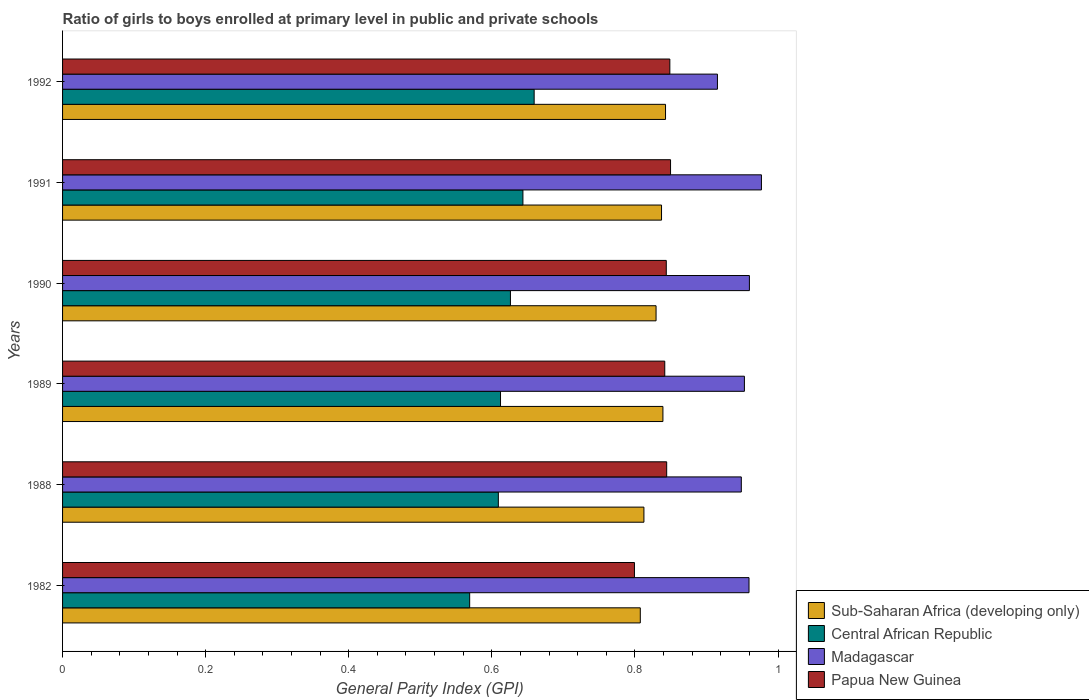How many different coloured bars are there?
Provide a short and direct response. 4. Are the number of bars per tick equal to the number of legend labels?
Offer a terse response. Yes. How many bars are there on the 6th tick from the bottom?
Offer a very short reply. 4. What is the label of the 5th group of bars from the top?
Make the answer very short. 1988. In how many cases, is the number of bars for a given year not equal to the number of legend labels?
Give a very brief answer. 0. What is the general parity index in Sub-Saharan Africa (developing only) in 1989?
Offer a terse response. 0.84. Across all years, what is the maximum general parity index in Papua New Guinea?
Make the answer very short. 0.85. Across all years, what is the minimum general parity index in Sub-Saharan Africa (developing only)?
Give a very brief answer. 0.81. In which year was the general parity index in Central African Republic maximum?
Your response must be concise. 1992. In which year was the general parity index in Madagascar minimum?
Offer a terse response. 1992. What is the total general parity index in Sub-Saharan Africa (developing only) in the graph?
Provide a succinct answer. 4.97. What is the difference between the general parity index in Sub-Saharan Africa (developing only) in 1988 and that in 1989?
Make the answer very short. -0.03. What is the difference between the general parity index in Sub-Saharan Africa (developing only) in 1991 and the general parity index in Papua New Guinea in 1989?
Ensure brevity in your answer.  -0. What is the average general parity index in Papua New Guinea per year?
Your answer should be very brief. 0.84. In the year 1992, what is the difference between the general parity index in Sub-Saharan Africa (developing only) and general parity index in Madagascar?
Ensure brevity in your answer.  -0.07. What is the ratio of the general parity index in Central African Republic in 1989 to that in 1991?
Provide a short and direct response. 0.95. Is the general parity index in Madagascar in 1989 less than that in 1991?
Offer a very short reply. Yes. Is the difference between the general parity index in Sub-Saharan Africa (developing only) in 1988 and 1992 greater than the difference between the general parity index in Madagascar in 1988 and 1992?
Make the answer very short. No. What is the difference between the highest and the second highest general parity index in Papua New Guinea?
Your response must be concise. 0. What is the difference between the highest and the lowest general parity index in Papua New Guinea?
Keep it short and to the point. 0.05. Is it the case that in every year, the sum of the general parity index in Papua New Guinea and general parity index in Central African Republic is greater than the sum of general parity index in Sub-Saharan Africa (developing only) and general parity index in Madagascar?
Offer a very short reply. No. What does the 3rd bar from the top in 1982 represents?
Your answer should be compact. Central African Republic. What does the 1st bar from the bottom in 1992 represents?
Offer a very short reply. Sub-Saharan Africa (developing only). Is it the case that in every year, the sum of the general parity index in Central African Republic and general parity index in Madagascar is greater than the general parity index in Sub-Saharan Africa (developing only)?
Ensure brevity in your answer.  Yes. What is the difference between two consecutive major ticks on the X-axis?
Your answer should be very brief. 0.2. Are the values on the major ticks of X-axis written in scientific E-notation?
Provide a short and direct response. No. Does the graph contain any zero values?
Give a very brief answer. No. Does the graph contain grids?
Provide a short and direct response. No. Where does the legend appear in the graph?
Keep it short and to the point. Bottom right. How are the legend labels stacked?
Keep it short and to the point. Vertical. What is the title of the graph?
Keep it short and to the point. Ratio of girls to boys enrolled at primary level in public and private schools. What is the label or title of the X-axis?
Offer a terse response. General Parity Index (GPI). What is the label or title of the Y-axis?
Your answer should be compact. Years. What is the General Parity Index (GPI) in Sub-Saharan Africa (developing only) in 1982?
Offer a very short reply. 0.81. What is the General Parity Index (GPI) in Central African Republic in 1982?
Your answer should be compact. 0.57. What is the General Parity Index (GPI) in Madagascar in 1982?
Provide a short and direct response. 0.96. What is the General Parity Index (GPI) in Papua New Guinea in 1982?
Ensure brevity in your answer.  0.8. What is the General Parity Index (GPI) of Sub-Saharan Africa (developing only) in 1988?
Provide a short and direct response. 0.81. What is the General Parity Index (GPI) in Central African Republic in 1988?
Keep it short and to the point. 0.61. What is the General Parity Index (GPI) in Madagascar in 1988?
Provide a short and direct response. 0.95. What is the General Parity Index (GPI) of Papua New Guinea in 1988?
Make the answer very short. 0.84. What is the General Parity Index (GPI) of Sub-Saharan Africa (developing only) in 1989?
Your answer should be very brief. 0.84. What is the General Parity Index (GPI) in Central African Republic in 1989?
Provide a short and direct response. 0.61. What is the General Parity Index (GPI) in Madagascar in 1989?
Ensure brevity in your answer.  0.95. What is the General Parity Index (GPI) of Papua New Guinea in 1989?
Provide a succinct answer. 0.84. What is the General Parity Index (GPI) of Sub-Saharan Africa (developing only) in 1990?
Provide a succinct answer. 0.83. What is the General Parity Index (GPI) of Central African Republic in 1990?
Your response must be concise. 0.63. What is the General Parity Index (GPI) in Papua New Guinea in 1990?
Offer a terse response. 0.84. What is the General Parity Index (GPI) of Sub-Saharan Africa (developing only) in 1991?
Your answer should be very brief. 0.84. What is the General Parity Index (GPI) in Central African Republic in 1991?
Offer a very short reply. 0.64. What is the General Parity Index (GPI) in Madagascar in 1991?
Ensure brevity in your answer.  0.98. What is the General Parity Index (GPI) of Papua New Guinea in 1991?
Offer a terse response. 0.85. What is the General Parity Index (GPI) in Sub-Saharan Africa (developing only) in 1992?
Give a very brief answer. 0.84. What is the General Parity Index (GPI) of Central African Republic in 1992?
Ensure brevity in your answer.  0.66. What is the General Parity Index (GPI) of Madagascar in 1992?
Ensure brevity in your answer.  0.92. What is the General Parity Index (GPI) in Papua New Guinea in 1992?
Keep it short and to the point. 0.85. Across all years, what is the maximum General Parity Index (GPI) of Sub-Saharan Africa (developing only)?
Provide a succinct answer. 0.84. Across all years, what is the maximum General Parity Index (GPI) in Central African Republic?
Your answer should be very brief. 0.66. Across all years, what is the maximum General Parity Index (GPI) in Madagascar?
Provide a short and direct response. 0.98. Across all years, what is the maximum General Parity Index (GPI) of Papua New Guinea?
Provide a short and direct response. 0.85. Across all years, what is the minimum General Parity Index (GPI) of Sub-Saharan Africa (developing only)?
Provide a succinct answer. 0.81. Across all years, what is the minimum General Parity Index (GPI) in Central African Republic?
Your answer should be compact. 0.57. Across all years, what is the minimum General Parity Index (GPI) of Madagascar?
Your answer should be compact. 0.92. Across all years, what is the minimum General Parity Index (GPI) of Papua New Guinea?
Offer a terse response. 0.8. What is the total General Parity Index (GPI) of Sub-Saharan Africa (developing only) in the graph?
Make the answer very short. 4.97. What is the total General Parity Index (GPI) of Central African Republic in the graph?
Offer a terse response. 3.72. What is the total General Parity Index (GPI) in Madagascar in the graph?
Your response must be concise. 5.71. What is the total General Parity Index (GPI) in Papua New Guinea in the graph?
Offer a terse response. 5.03. What is the difference between the General Parity Index (GPI) of Sub-Saharan Africa (developing only) in 1982 and that in 1988?
Ensure brevity in your answer.  -0.01. What is the difference between the General Parity Index (GPI) of Central African Republic in 1982 and that in 1988?
Keep it short and to the point. -0.04. What is the difference between the General Parity Index (GPI) in Madagascar in 1982 and that in 1988?
Provide a succinct answer. 0.01. What is the difference between the General Parity Index (GPI) of Papua New Guinea in 1982 and that in 1988?
Your answer should be compact. -0.05. What is the difference between the General Parity Index (GPI) in Sub-Saharan Africa (developing only) in 1982 and that in 1989?
Provide a short and direct response. -0.03. What is the difference between the General Parity Index (GPI) of Central African Republic in 1982 and that in 1989?
Your response must be concise. -0.04. What is the difference between the General Parity Index (GPI) in Madagascar in 1982 and that in 1989?
Give a very brief answer. 0.01. What is the difference between the General Parity Index (GPI) of Papua New Guinea in 1982 and that in 1989?
Your answer should be very brief. -0.04. What is the difference between the General Parity Index (GPI) of Sub-Saharan Africa (developing only) in 1982 and that in 1990?
Provide a succinct answer. -0.02. What is the difference between the General Parity Index (GPI) of Central African Republic in 1982 and that in 1990?
Your answer should be very brief. -0.06. What is the difference between the General Parity Index (GPI) in Madagascar in 1982 and that in 1990?
Provide a succinct answer. -0. What is the difference between the General Parity Index (GPI) in Papua New Guinea in 1982 and that in 1990?
Give a very brief answer. -0.04. What is the difference between the General Parity Index (GPI) in Sub-Saharan Africa (developing only) in 1982 and that in 1991?
Your answer should be compact. -0.03. What is the difference between the General Parity Index (GPI) of Central African Republic in 1982 and that in 1991?
Offer a very short reply. -0.07. What is the difference between the General Parity Index (GPI) of Madagascar in 1982 and that in 1991?
Keep it short and to the point. -0.02. What is the difference between the General Parity Index (GPI) of Papua New Guinea in 1982 and that in 1991?
Your answer should be very brief. -0.05. What is the difference between the General Parity Index (GPI) in Sub-Saharan Africa (developing only) in 1982 and that in 1992?
Give a very brief answer. -0.04. What is the difference between the General Parity Index (GPI) in Central African Republic in 1982 and that in 1992?
Your answer should be compact. -0.09. What is the difference between the General Parity Index (GPI) in Madagascar in 1982 and that in 1992?
Provide a short and direct response. 0.04. What is the difference between the General Parity Index (GPI) of Papua New Guinea in 1982 and that in 1992?
Your answer should be very brief. -0.05. What is the difference between the General Parity Index (GPI) of Sub-Saharan Africa (developing only) in 1988 and that in 1989?
Give a very brief answer. -0.03. What is the difference between the General Parity Index (GPI) in Central African Republic in 1988 and that in 1989?
Provide a short and direct response. -0. What is the difference between the General Parity Index (GPI) in Madagascar in 1988 and that in 1989?
Offer a terse response. -0. What is the difference between the General Parity Index (GPI) of Papua New Guinea in 1988 and that in 1989?
Your answer should be compact. 0. What is the difference between the General Parity Index (GPI) of Sub-Saharan Africa (developing only) in 1988 and that in 1990?
Your answer should be compact. -0.02. What is the difference between the General Parity Index (GPI) of Central African Republic in 1988 and that in 1990?
Your answer should be compact. -0.02. What is the difference between the General Parity Index (GPI) in Madagascar in 1988 and that in 1990?
Offer a very short reply. -0.01. What is the difference between the General Parity Index (GPI) of Papua New Guinea in 1988 and that in 1990?
Provide a short and direct response. 0. What is the difference between the General Parity Index (GPI) in Sub-Saharan Africa (developing only) in 1988 and that in 1991?
Give a very brief answer. -0.02. What is the difference between the General Parity Index (GPI) of Central African Republic in 1988 and that in 1991?
Provide a short and direct response. -0.03. What is the difference between the General Parity Index (GPI) in Madagascar in 1988 and that in 1991?
Make the answer very short. -0.03. What is the difference between the General Parity Index (GPI) in Papua New Guinea in 1988 and that in 1991?
Your response must be concise. -0.01. What is the difference between the General Parity Index (GPI) in Sub-Saharan Africa (developing only) in 1988 and that in 1992?
Give a very brief answer. -0.03. What is the difference between the General Parity Index (GPI) of Central African Republic in 1988 and that in 1992?
Offer a very short reply. -0.05. What is the difference between the General Parity Index (GPI) of Madagascar in 1988 and that in 1992?
Keep it short and to the point. 0.03. What is the difference between the General Parity Index (GPI) of Papua New Guinea in 1988 and that in 1992?
Offer a very short reply. -0. What is the difference between the General Parity Index (GPI) in Sub-Saharan Africa (developing only) in 1989 and that in 1990?
Ensure brevity in your answer.  0.01. What is the difference between the General Parity Index (GPI) of Central African Republic in 1989 and that in 1990?
Give a very brief answer. -0.01. What is the difference between the General Parity Index (GPI) of Madagascar in 1989 and that in 1990?
Your answer should be very brief. -0.01. What is the difference between the General Parity Index (GPI) in Papua New Guinea in 1989 and that in 1990?
Provide a short and direct response. -0. What is the difference between the General Parity Index (GPI) of Sub-Saharan Africa (developing only) in 1989 and that in 1991?
Your answer should be very brief. 0. What is the difference between the General Parity Index (GPI) in Central African Republic in 1989 and that in 1991?
Provide a succinct answer. -0.03. What is the difference between the General Parity Index (GPI) of Madagascar in 1989 and that in 1991?
Your response must be concise. -0.02. What is the difference between the General Parity Index (GPI) in Papua New Guinea in 1989 and that in 1991?
Your response must be concise. -0.01. What is the difference between the General Parity Index (GPI) of Sub-Saharan Africa (developing only) in 1989 and that in 1992?
Offer a terse response. -0. What is the difference between the General Parity Index (GPI) of Central African Republic in 1989 and that in 1992?
Provide a succinct answer. -0.05. What is the difference between the General Parity Index (GPI) of Madagascar in 1989 and that in 1992?
Give a very brief answer. 0.04. What is the difference between the General Parity Index (GPI) of Papua New Guinea in 1989 and that in 1992?
Your response must be concise. -0.01. What is the difference between the General Parity Index (GPI) in Sub-Saharan Africa (developing only) in 1990 and that in 1991?
Provide a succinct answer. -0.01. What is the difference between the General Parity Index (GPI) of Central African Republic in 1990 and that in 1991?
Keep it short and to the point. -0.02. What is the difference between the General Parity Index (GPI) of Madagascar in 1990 and that in 1991?
Make the answer very short. -0.02. What is the difference between the General Parity Index (GPI) of Papua New Guinea in 1990 and that in 1991?
Make the answer very short. -0.01. What is the difference between the General Parity Index (GPI) in Sub-Saharan Africa (developing only) in 1990 and that in 1992?
Offer a terse response. -0.01. What is the difference between the General Parity Index (GPI) in Central African Republic in 1990 and that in 1992?
Give a very brief answer. -0.03. What is the difference between the General Parity Index (GPI) of Madagascar in 1990 and that in 1992?
Keep it short and to the point. 0.04. What is the difference between the General Parity Index (GPI) of Papua New Guinea in 1990 and that in 1992?
Your answer should be very brief. -0.01. What is the difference between the General Parity Index (GPI) of Sub-Saharan Africa (developing only) in 1991 and that in 1992?
Offer a terse response. -0.01. What is the difference between the General Parity Index (GPI) of Central African Republic in 1991 and that in 1992?
Give a very brief answer. -0.02. What is the difference between the General Parity Index (GPI) of Madagascar in 1991 and that in 1992?
Keep it short and to the point. 0.06. What is the difference between the General Parity Index (GPI) of Sub-Saharan Africa (developing only) in 1982 and the General Parity Index (GPI) of Central African Republic in 1988?
Ensure brevity in your answer.  0.2. What is the difference between the General Parity Index (GPI) in Sub-Saharan Africa (developing only) in 1982 and the General Parity Index (GPI) in Madagascar in 1988?
Offer a very short reply. -0.14. What is the difference between the General Parity Index (GPI) of Sub-Saharan Africa (developing only) in 1982 and the General Parity Index (GPI) of Papua New Guinea in 1988?
Your answer should be compact. -0.04. What is the difference between the General Parity Index (GPI) in Central African Republic in 1982 and the General Parity Index (GPI) in Madagascar in 1988?
Make the answer very short. -0.38. What is the difference between the General Parity Index (GPI) in Central African Republic in 1982 and the General Parity Index (GPI) in Papua New Guinea in 1988?
Keep it short and to the point. -0.28. What is the difference between the General Parity Index (GPI) in Madagascar in 1982 and the General Parity Index (GPI) in Papua New Guinea in 1988?
Ensure brevity in your answer.  0.12. What is the difference between the General Parity Index (GPI) of Sub-Saharan Africa (developing only) in 1982 and the General Parity Index (GPI) of Central African Republic in 1989?
Offer a very short reply. 0.2. What is the difference between the General Parity Index (GPI) of Sub-Saharan Africa (developing only) in 1982 and the General Parity Index (GPI) of Madagascar in 1989?
Give a very brief answer. -0.15. What is the difference between the General Parity Index (GPI) in Sub-Saharan Africa (developing only) in 1982 and the General Parity Index (GPI) in Papua New Guinea in 1989?
Your answer should be compact. -0.03. What is the difference between the General Parity Index (GPI) of Central African Republic in 1982 and the General Parity Index (GPI) of Madagascar in 1989?
Provide a short and direct response. -0.38. What is the difference between the General Parity Index (GPI) in Central African Republic in 1982 and the General Parity Index (GPI) in Papua New Guinea in 1989?
Your response must be concise. -0.27. What is the difference between the General Parity Index (GPI) in Madagascar in 1982 and the General Parity Index (GPI) in Papua New Guinea in 1989?
Ensure brevity in your answer.  0.12. What is the difference between the General Parity Index (GPI) in Sub-Saharan Africa (developing only) in 1982 and the General Parity Index (GPI) in Central African Republic in 1990?
Provide a succinct answer. 0.18. What is the difference between the General Parity Index (GPI) of Sub-Saharan Africa (developing only) in 1982 and the General Parity Index (GPI) of Madagascar in 1990?
Provide a short and direct response. -0.15. What is the difference between the General Parity Index (GPI) in Sub-Saharan Africa (developing only) in 1982 and the General Parity Index (GPI) in Papua New Guinea in 1990?
Your response must be concise. -0.04. What is the difference between the General Parity Index (GPI) of Central African Republic in 1982 and the General Parity Index (GPI) of Madagascar in 1990?
Ensure brevity in your answer.  -0.39. What is the difference between the General Parity Index (GPI) in Central African Republic in 1982 and the General Parity Index (GPI) in Papua New Guinea in 1990?
Your answer should be compact. -0.27. What is the difference between the General Parity Index (GPI) of Madagascar in 1982 and the General Parity Index (GPI) of Papua New Guinea in 1990?
Your answer should be compact. 0.12. What is the difference between the General Parity Index (GPI) in Sub-Saharan Africa (developing only) in 1982 and the General Parity Index (GPI) in Central African Republic in 1991?
Keep it short and to the point. 0.16. What is the difference between the General Parity Index (GPI) in Sub-Saharan Africa (developing only) in 1982 and the General Parity Index (GPI) in Madagascar in 1991?
Provide a succinct answer. -0.17. What is the difference between the General Parity Index (GPI) of Sub-Saharan Africa (developing only) in 1982 and the General Parity Index (GPI) of Papua New Guinea in 1991?
Provide a short and direct response. -0.04. What is the difference between the General Parity Index (GPI) in Central African Republic in 1982 and the General Parity Index (GPI) in Madagascar in 1991?
Provide a short and direct response. -0.41. What is the difference between the General Parity Index (GPI) of Central African Republic in 1982 and the General Parity Index (GPI) of Papua New Guinea in 1991?
Provide a short and direct response. -0.28. What is the difference between the General Parity Index (GPI) of Madagascar in 1982 and the General Parity Index (GPI) of Papua New Guinea in 1991?
Ensure brevity in your answer.  0.11. What is the difference between the General Parity Index (GPI) of Sub-Saharan Africa (developing only) in 1982 and the General Parity Index (GPI) of Central African Republic in 1992?
Your answer should be compact. 0.15. What is the difference between the General Parity Index (GPI) of Sub-Saharan Africa (developing only) in 1982 and the General Parity Index (GPI) of Madagascar in 1992?
Ensure brevity in your answer.  -0.11. What is the difference between the General Parity Index (GPI) in Sub-Saharan Africa (developing only) in 1982 and the General Parity Index (GPI) in Papua New Guinea in 1992?
Your answer should be very brief. -0.04. What is the difference between the General Parity Index (GPI) in Central African Republic in 1982 and the General Parity Index (GPI) in Madagascar in 1992?
Your answer should be compact. -0.35. What is the difference between the General Parity Index (GPI) of Central African Republic in 1982 and the General Parity Index (GPI) of Papua New Guinea in 1992?
Offer a terse response. -0.28. What is the difference between the General Parity Index (GPI) of Madagascar in 1982 and the General Parity Index (GPI) of Papua New Guinea in 1992?
Your answer should be very brief. 0.11. What is the difference between the General Parity Index (GPI) in Sub-Saharan Africa (developing only) in 1988 and the General Parity Index (GPI) in Central African Republic in 1989?
Give a very brief answer. 0.2. What is the difference between the General Parity Index (GPI) of Sub-Saharan Africa (developing only) in 1988 and the General Parity Index (GPI) of Madagascar in 1989?
Ensure brevity in your answer.  -0.14. What is the difference between the General Parity Index (GPI) of Sub-Saharan Africa (developing only) in 1988 and the General Parity Index (GPI) of Papua New Guinea in 1989?
Offer a terse response. -0.03. What is the difference between the General Parity Index (GPI) in Central African Republic in 1988 and the General Parity Index (GPI) in Madagascar in 1989?
Ensure brevity in your answer.  -0.34. What is the difference between the General Parity Index (GPI) in Central African Republic in 1988 and the General Parity Index (GPI) in Papua New Guinea in 1989?
Make the answer very short. -0.23. What is the difference between the General Parity Index (GPI) of Madagascar in 1988 and the General Parity Index (GPI) of Papua New Guinea in 1989?
Make the answer very short. 0.11. What is the difference between the General Parity Index (GPI) of Sub-Saharan Africa (developing only) in 1988 and the General Parity Index (GPI) of Central African Republic in 1990?
Make the answer very short. 0.19. What is the difference between the General Parity Index (GPI) in Sub-Saharan Africa (developing only) in 1988 and the General Parity Index (GPI) in Madagascar in 1990?
Your answer should be compact. -0.15. What is the difference between the General Parity Index (GPI) in Sub-Saharan Africa (developing only) in 1988 and the General Parity Index (GPI) in Papua New Guinea in 1990?
Give a very brief answer. -0.03. What is the difference between the General Parity Index (GPI) in Central African Republic in 1988 and the General Parity Index (GPI) in Madagascar in 1990?
Your response must be concise. -0.35. What is the difference between the General Parity Index (GPI) in Central African Republic in 1988 and the General Parity Index (GPI) in Papua New Guinea in 1990?
Your answer should be very brief. -0.23. What is the difference between the General Parity Index (GPI) of Madagascar in 1988 and the General Parity Index (GPI) of Papua New Guinea in 1990?
Offer a very short reply. 0.1. What is the difference between the General Parity Index (GPI) of Sub-Saharan Africa (developing only) in 1988 and the General Parity Index (GPI) of Central African Republic in 1991?
Ensure brevity in your answer.  0.17. What is the difference between the General Parity Index (GPI) in Sub-Saharan Africa (developing only) in 1988 and the General Parity Index (GPI) in Madagascar in 1991?
Give a very brief answer. -0.16. What is the difference between the General Parity Index (GPI) of Sub-Saharan Africa (developing only) in 1988 and the General Parity Index (GPI) of Papua New Guinea in 1991?
Provide a succinct answer. -0.04. What is the difference between the General Parity Index (GPI) in Central African Republic in 1988 and the General Parity Index (GPI) in Madagascar in 1991?
Your answer should be very brief. -0.37. What is the difference between the General Parity Index (GPI) of Central African Republic in 1988 and the General Parity Index (GPI) of Papua New Guinea in 1991?
Your response must be concise. -0.24. What is the difference between the General Parity Index (GPI) in Madagascar in 1988 and the General Parity Index (GPI) in Papua New Guinea in 1991?
Provide a succinct answer. 0.1. What is the difference between the General Parity Index (GPI) in Sub-Saharan Africa (developing only) in 1988 and the General Parity Index (GPI) in Central African Republic in 1992?
Make the answer very short. 0.15. What is the difference between the General Parity Index (GPI) in Sub-Saharan Africa (developing only) in 1988 and the General Parity Index (GPI) in Madagascar in 1992?
Provide a short and direct response. -0.1. What is the difference between the General Parity Index (GPI) in Sub-Saharan Africa (developing only) in 1988 and the General Parity Index (GPI) in Papua New Guinea in 1992?
Offer a very short reply. -0.04. What is the difference between the General Parity Index (GPI) of Central African Republic in 1988 and the General Parity Index (GPI) of Madagascar in 1992?
Offer a terse response. -0.31. What is the difference between the General Parity Index (GPI) in Central African Republic in 1988 and the General Parity Index (GPI) in Papua New Guinea in 1992?
Your answer should be very brief. -0.24. What is the difference between the General Parity Index (GPI) of Madagascar in 1988 and the General Parity Index (GPI) of Papua New Guinea in 1992?
Provide a succinct answer. 0.1. What is the difference between the General Parity Index (GPI) in Sub-Saharan Africa (developing only) in 1989 and the General Parity Index (GPI) in Central African Republic in 1990?
Give a very brief answer. 0.21. What is the difference between the General Parity Index (GPI) in Sub-Saharan Africa (developing only) in 1989 and the General Parity Index (GPI) in Madagascar in 1990?
Provide a short and direct response. -0.12. What is the difference between the General Parity Index (GPI) of Sub-Saharan Africa (developing only) in 1989 and the General Parity Index (GPI) of Papua New Guinea in 1990?
Provide a succinct answer. -0. What is the difference between the General Parity Index (GPI) in Central African Republic in 1989 and the General Parity Index (GPI) in Madagascar in 1990?
Keep it short and to the point. -0.35. What is the difference between the General Parity Index (GPI) in Central African Republic in 1989 and the General Parity Index (GPI) in Papua New Guinea in 1990?
Your response must be concise. -0.23. What is the difference between the General Parity Index (GPI) in Madagascar in 1989 and the General Parity Index (GPI) in Papua New Guinea in 1990?
Keep it short and to the point. 0.11. What is the difference between the General Parity Index (GPI) of Sub-Saharan Africa (developing only) in 1989 and the General Parity Index (GPI) of Central African Republic in 1991?
Give a very brief answer. 0.2. What is the difference between the General Parity Index (GPI) in Sub-Saharan Africa (developing only) in 1989 and the General Parity Index (GPI) in Madagascar in 1991?
Give a very brief answer. -0.14. What is the difference between the General Parity Index (GPI) in Sub-Saharan Africa (developing only) in 1989 and the General Parity Index (GPI) in Papua New Guinea in 1991?
Make the answer very short. -0.01. What is the difference between the General Parity Index (GPI) of Central African Republic in 1989 and the General Parity Index (GPI) of Madagascar in 1991?
Your answer should be very brief. -0.36. What is the difference between the General Parity Index (GPI) of Central African Republic in 1989 and the General Parity Index (GPI) of Papua New Guinea in 1991?
Ensure brevity in your answer.  -0.24. What is the difference between the General Parity Index (GPI) in Madagascar in 1989 and the General Parity Index (GPI) in Papua New Guinea in 1991?
Your answer should be very brief. 0.1. What is the difference between the General Parity Index (GPI) of Sub-Saharan Africa (developing only) in 1989 and the General Parity Index (GPI) of Central African Republic in 1992?
Provide a short and direct response. 0.18. What is the difference between the General Parity Index (GPI) of Sub-Saharan Africa (developing only) in 1989 and the General Parity Index (GPI) of Madagascar in 1992?
Your answer should be very brief. -0.08. What is the difference between the General Parity Index (GPI) in Sub-Saharan Africa (developing only) in 1989 and the General Parity Index (GPI) in Papua New Guinea in 1992?
Your answer should be compact. -0.01. What is the difference between the General Parity Index (GPI) in Central African Republic in 1989 and the General Parity Index (GPI) in Madagascar in 1992?
Your answer should be very brief. -0.3. What is the difference between the General Parity Index (GPI) of Central African Republic in 1989 and the General Parity Index (GPI) of Papua New Guinea in 1992?
Ensure brevity in your answer.  -0.24. What is the difference between the General Parity Index (GPI) of Madagascar in 1989 and the General Parity Index (GPI) of Papua New Guinea in 1992?
Your response must be concise. 0.1. What is the difference between the General Parity Index (GPI) of Sub-Saharan Africa (developing only) in 1990 and the General Parity Index (GPI) of Central African Republic in 1991?
Provide a short and direct response. 0.19. What is the difference between the General Parity Index (GPI) in Sub-Saharan Africa (developing only) in 1990 and the General Parity Index (GPI) in Madagascar in 1991?
Your answer should be compact. -0.15. What is the difference between the General Parity Index (GPI) in Sub-Saharan Africa (developing only) in 1990 and the General Parity Index (GPI) in Papua New Guinea in 1991?
Provide a succinct answer. -0.02. What is the difference between the General Parity Index (GPI) in Central African Republic in 1990 and the General Parity Index (GPI) in Madagascar in 1991?
Give a very brief answer. -0.35. What is the difference between the General Parity Index (GPI) in Central African Republic in 1990 and the General Parity Index (GPI) in Papua New Guinea in 1991?
Provide a succinct answer. -0.22. What is the difference between the General Parity Index (GPI) of Madagascar in 1990 and the General Parity Index (GPI) of Papua New Guinea in 1991?
Give a very brief answer. 0.11. What is the difference between the General Parity Index (GPI) in Sub-Saharan Africa (developing only) in 1990 and the General Parity Index (GPI) in Central African Republic in 1992?
Your answer should be compact. 0.17. What is the difference between the General Parity Index (GPI) in Sub-Saharan Africa (developing only) in 1990 and the General Parity Index (GPI) in Madagascar in 1992?
Provide a short and direct response. -0.09. What is the difference between the General Parity Index (GPI) of Sub-Saharan Africa (developing only) in 1990 and the General Parity Index (GPI) of Papua New Guinea in 1992?
Provide a short and direct response. -0.02. What is the difference between the General Parity Index (GPI) of Central African Republic in 1990 and the General Parity Index (GPI) of Madagascar in 1992?
Offer a very short reply. -0.29. What is the difference between the General Parity Index (GPI) in Central African Republic in 1990 and the General Parity Index (GPI) in Papua New Guinea in 1992?
Your answer should be compact. -0.22. What is the difference between the General Parity Index (GPI) of Madagascar in 1990 and the General Parity Index (GPI) of Papua New Guinea in 1992?
Provide a succinct answer. 0.11. What is the difference between the General Parity Index (GPI) in Sub-Saharan Africa (developing only) in 1991 and the General Parity Index (GPI) in Central African Republic in 1992?
Your answer should be compact. 0.18. What is the difference between the General Parity Index (GPI) in Sub-Saharan Africa (developing only) in 1991 and the General Parity Index (GPI) in Madagascar in 1992?
Give a very brief answer. -0.08. What is the difference between the General Parity Index (GPI) of Sub-Saharan Africa (developing only) in 1991 and the General Parity Index (GPI) of Papua New Guinea in 1992?
Ensure brevity in your answer.  -0.01. What is the difference between the General Parity Index (GPI) of Central African Republic in 1991 and the General Parity Index (GPI) of Madagascar in 1992?
Offer a terse response. -0.27. What is the difference between the General Parity Index (GPI) in Central African Republic in 1991 and the General Parity Index (GPI) in Papua New Guinea in 1992?
Offer a terse response. -0.21. What is the difference between the General Parity Index (GPI) of Madagascar in 1991 and the General Parity Index (GPI) of Papua New Guinea in 1992?
Provide a short and direct response. 0.13. What is the average General Parity Index (GPI) in Sub-Saharan Africa (developing only) per year?
Your answer should be compact. 0.83. What is the average General Parity Index (GPI) of Central African Republic per year?
Give a very brief answer. 0.62. What is the average General Parity Index (GPI) in Madagascar per year?
Offer a very short reply. 0.95. What is the average General Parity Index (GPI) of Papua New Guinea per year?
Offer a very short reply. 0.84. In the year 1982, what is the difference between the General Parity Index (GPI) in Sub-Saharan Africa (developing only) and General Parity Index (GPI) in Central African Republic?
Keep it short and to the point. 0.24. In the year 1982, what is the difference between the General Parity Index (GPI) in Sub-Saharan Africa (developing only) and General Parity Index (GPI) in Madagascar?
Provide a succinct answer. -0.15. In the year 1982, what is the difference between the General Parity Index (GPI) in Sub-Saharan Africa (developing only) and General Parity Index (GPI) in Papua New Guinea?
Keep it short and to the point. 0.01. In the year 1982, what is the difference between the General Parity Index (GPI) of Central African Republic and General Parity Index (GPI) of Madagascar?
Ensure brevity in your answer.  -0.39. In the year 1982, what is the difference between the General Parity Index (GPI) of Central African Republic and General Parity Index (GPI) of Papua New Guinea?
Offer a terse response. -0.23. In the year 1982, what is the difference between the General Parity Index (GPI) in Madagascar and General Parity Index (GPI) in Papua New Guinea?
Make the answer very short. 0.16. In the year 1988, what is the difference between the General Parity Index (GPI) of Sub-Saharan Africa (developing only) and General Parity Index (GPI) of Central African Republic?
Offer a very short reply. 0.2. In the year 1988, what is the difference between the General Parity Index (GPI) of Sub-Saharan Africa (developing only) and General Parity Index (GPI) of Madagascar?
Offer a terse response. -0.14. In the year 1988, what is the difference between the General Parity Index (GPI) of Sub-Saharan Africa (developing only) and General Parity Index (GPI) of Papua New Guinea?
Your answer should be compact. -0.03. In the year 1988, what is the difference between the General Parity Index (GPI) of Central African Republic and General Parity Index (GPI) of Madagascar?
Keep it short and to the point. -0.34. In the year 1988, what is the difference between the General Parity Index (GPI) of Central African Republic and General Parity Index (GPI) of Papua New Guinea?
Offer a terse response. -0.24. In the year 1988, what is the difference between the General Parity Index (GPI) in Madagascar and General Parity Index (GPI) in Papua New Guinea?
Give a very brief answer. 0.1. In the year 1989, what is the difference between the General Parity Index (GPI) in Sub-Saharan Africa (developing only) and General Parity Index (GPI) in Central African Republic?
Keep it short and to the point. 0.23. In the year 1989, what is the difference between the General Parity Index (GPI) of Sub-Saharan Africa (developing only) and General Parity Index (GPI) of Madagascar?
Offer a very short reply. -0.11. In the year 1989, what is the difference between the General Parity Index (GPI) of Sub-Saharan Africa (developing only) and General Parity Index (GPI) of Papua New Guinea?
Offer a very short reply. -0. In the year 1989, what is the difference between the General Parity Index (GPI) in Central African Republic and General Parity Index (GPI) in Madagascar?
Ensure brevity in your answer.  -0.34. In the year 1989, what is the difference between the General Parity Index (GPI) in Central African Republic and General Parity Index (GPI) in Papua New Guinea?
Make the answer very short. -0.23. In the year 1989, what is the difference between the General Parity Index (GPI) of Madagascar and General Parity Index (GPI) of Papua New Guinea?
Offer a very short reply. 0.11. In the year 1990, what is the difference between the General Parity Index (GPI) of Sub-Saharan Africa (developing only) and General Parity Index (GPI) of Central African Republic?
Provide a short and direct response. 0.2. In the year 1990, what is the difference between the General Parity Index (GPI) in Sub-Saharan Africa (developing only) and General Parity Index (GPI) in Madagascar?
Give a very brief answer. -0.13. In the year 1990, what is the difference between the General Parity Index (GPI) of Sub-Saharan Africa (developing only) and General Parity Index (GPI) of Papua New Guinea?
Your answer should be very brief. -0.01. In the year 1990, what is the difference between the General Parity Index (GPI) of Central African Republic and General Parity Index (GPI) of Madagascar?
Offer a very short reply. -0.33. In the year 1990, what is the difference between the General Parity Index (GPI) in Central African Republic and General Parity Index (GPI) in Papua New Guinea?
Keep it short and to the point. -0.22. In the year 1990, what is the difference between the General Parity Index (GPI) of Madagascar and General Parity Index (GPI) of Papua New Guinea?
Make the answer very short. 0.12. In the year 1991, what is the difference between the General Parity Index (GPI) of Sub-Saharan Africa (developing only) and General Parity Index (GPI) of Central African Republic?
Your answer should be compact. 0.19. In the year 1991, what is the difference between the General Parity Index (GPI) of Sub-Saharan Africa (developing only) and General Parity Index (GPI) of Madagascar?
Give a very brief answer. -0.14. In the year 1991, what is the difference between the General Parity Index (GPI) in Sub-Saharan Africa (developing only) and General Parity Index (GPI) in Papua New Guinea?
Ensure brevity in your answer.  -0.01. In the year 1991, what is the difference between the General Parity Index (GPI) in Central African Republic and General Parity Index (GPI) in Madagascar?
Your answer should be compact. -0.33. In the year 1991, what is the difference between the General Parity Index (GPI) in Central African Republic and General Parity Index (GPI) in Papua New Guinea?
Offer a terse response. -0.21. In the year 1991, what is the difference between the General Parity Index (GPI) in Madagascar and General Parity Index (GPI) in Papua New Guinea?
Your answer should be compact. 0.13. In the year 1992, what is the difference between the General Parity Index (GPI) of Sub-Saharan Africa (developing only) and General Parity Index (GPI) of Central African Republic?
Your answer should be compact. 0.18. In the year 1992, what is the difference between the General Parity Index (GPI) of Sub-Saharan Africa (developing only) and General Parity Index (GPI) of Madagascar?
Offer a very short reply. -0.07. In the year 1992, what is the difference between the General Parity Index (GPI) of Sub-Saharan Africa (developing only) and General Parity Index (GPI) of Papua New Guinea?
Give a very brief answer. -0.01. In the year 1992, what is the difference between the General Parity Index (GPI) in Central African Republic and General Parity Index (GPI) in Madagascar?
Your answer should be compact. -0.26. In the year 1992, what is the difference between the General Parity Index (GPI) of Central African Republic and General Parity Index (GPI) of Papua New Guinea?
Your answer should be compact. -0.19. In the year 1992, what is the difference between the General Parity Index (GPI) of Madagascar and General Parity Index (GPI) of Papua New Guinea?
Provide a short and direct response. 0.07. What is the ratio of the General Parity Index (GPI) in Central African Republic in 1982 to that in 1988?
Give a very brief answer. 0.93. What is the ratio of the General Parity Index (GPI) of Madagascar in 1982 to that in 1988?
Provide a succinct answer. 1.01. What is the ratio of the General Parity Index (GPI) in Papua New Guinea in 1982 to that in 1988?
Your answer should be very brief. 0.95. What is the ratio of the General Parity Index (GPI) in Sub-Saharan Africa (developing only) in 1982 to that in 1989?
Offer a very short reply. 0.96. What is the ratio of the General Parity Index (GPI) in Central African Republic in 1982 to that in 1989?
Ensure brevity in your answer.  0.93. What is the ratio of the General Parity Index (GPI) of Madagascar in 1982 to that in 1989?
Ensure brevity in your answer.  1.01. What is the ratio of the General Parity Index (GPI) of Papua New Guinea in 1982 to that in 1989?
Keep it short and to the point. 0.95. What is the ratio of the General Parity Index (GPI) of Sub-Saharan Africa (developing only) in 1982 to that in 1990?
Your answer should be compact. 0.97. What is the ratio of the General Parity Index (GPI) in Central African Republic in 1982 to that in 1990?
Ensure brevity in your answer.  0.91. What is the ratio of the General Parity Index (GPI) of Papua New Guinea in 1982 to that in 1990?
Your answer should be compact. 0.95. What is the ratio of the General Parity Index (GPI) of Sub-Saharan Africa (developing only) in 1982 to that in 1991?
Offer a very short reply. 0.96. What is the ratio of the General Parity Index (GPI) in Central African Republic in 1982 to that in 1991?
Ensure brevity in your answer.  0.88. What is the ratio of the General Parity Index (GPI) in Madagascar in 1982 to that in 1991?
Make the answer very short. 0.98. What is the ratio of the General Parity Index (GPI) in Papua New Guinea in 1982 to that in 1991?
Keep it short and to the point. 0.94. What is the ratio of the General Parity Index (GPI) in Sub-Saharan Africa (developing only) in 1982 to that in 1992?
Provide a short and direct response. 0.96. What is the ratio of the General Parity Index (GPI) in Central African Republic in 1982 to that in 1992?
Your response must be concise. 0.86. What is the ratio of the General Parity Index (GPI) of Madagascar in 1982 to that in 1992?
Keep it short and to the point. 1.05. What is the ratio of the General Parity Index (GPI) in Papua New Guinea in 1982 to that in 1992?
Provide a short and direct response. 0.94. What is the ratio of the General Parity Index (GPI) in Sub-Saharan Africa (developing only) in 1988 to that in 1989?
Keep it short and to the point. 0.97. What is the ratio of the General Parity Index (GPI) of Central African Republic in 1988 to that in 1989?
Your answer should be very brief. 0.99. What is the ratio of the General Parity Index (GPI) in Madagascar in 1988 to that in 1989?
Your answer should be compact. 1. What is the ratio of the General Parity Index (GPI) of Sub-Saharan Africa (developing only) in 1988 to that in 1990?
Give a very brief answer. 0.98. What is the ratio of the General Parity Index (GPI) of Central African Republic in 1988 to that in 1990?
Ensure brevity in your answer.  0.97. What is the ratio of the General Parity Index (GPI) in Sub-Saharan Africa (developing only) in 1988 to that in 1991?
Offer a very short reply. 0.97. What is the ratio of the General Parity Index (GPI) in Central African Republic in 1988 to that in 1991?
Your answer should be very brief. 0.95. What is the ratio of the General Parity Index (GPI) of Madagascar in 1988 to that in 1991?
Ensure brevity in your answer.  0.97. What is the ratio of the General Parity Index (GPI) of Sub-Saharan Africa (developing only) in 1988 to that in 1992?
Offer a very short reply. 0.96. What is the ratio of the General Parity Index (GPI) in Central African Republic in 1988 to that in 1992?
Make the answer very short. 0.92. What is the ratio of the General Parity Index (GPI) in Madagascar in 1988 to that in 1992?
Your answer should be compact. 1.04. What is the ratio of the General Parity Index (GPI) of Papua New Guinea in 1988 to that in 1992?
Ensure brevity in your answer.  0.99. What is the ratio of the General Parity Index (GPI) of Sub-Saharan Africa (developing only) in 1989 to that in 1990?
Offer a terse response. 1.01. What is the ratio of the General Parity Index (GPI) of Central African Republic in 1989 to that in 1990?
Offer a very short reply. 0.98. What is the ratio of the General Parity Index (GPI) in Madagascar in 1989 to that in 1990?
Give a very brief answer. 0.99. What is the ratio of the General Parity Index (GPI) in Central African Republic in 1989 to that in 1991?
Make the answer very short. 0.95. What is the ratio of the General Parity Index (GPI) in Madagascar in 1989 to that in 1991?
Provide a succinct answer. 0.98. What is the ratio of the General Parity Index (GPI) of Central African Republic in 1989 to that in 1992?
Provide a short and direct response. 0.93. What is the ratio of the General Parity Index (GPI) of Madagascar in 1989 to that in 1992?
Offer a terse response. 1.04. What is the ratio of the General Parity Index (GPI) in Sub-Saharan Africa (developing only) in 1990 to that in 1991?
Keep it short and to the point. 0.99. What is the ratio of the General Parity Index (GPI) of Central African Republic in 1990 to that in 1991?
Make the answer very short. 0.97. What is the ratio of the General Parity Index (GPI) of Madagascar in 1990 to that in 1991?
Your response must be concise. 0.98. What is the ratio of the General Parity Index (GPI) in Sub-Saharan Africa (developing only) in 1990 to that in 1992?
Offer a very short reply. 0.98. What is the ratio of the General Parity Index (GPI) of Central African Republic in 1990 to that in 1992?
Offer a very short reply. 0.95. What is the ratio of the General Parity Index (GPI) of Madagascar in 1990 to that in 1992?
Your response must be concise. 1.05. What is the ratio of the General Parity Index (GPI) in Papua New Guinea in 1990 to that in 1992?
Ensure brevity in your answer.  0.99. What is the ratio of the General Parity Index (GPI) of Sub-Saharan Africa (developing only) in 1991 to that in 1992?
Give a very brief answer. 0.99. What is the ratio of the General Parity Index (GPI) of Central African Republic in 1991 to that in 1992?
Your answer should be compact. 0.98. What is the ratio of the General Parity Index (GPI) of Madagascar in 1991 to that in 1992?
Give a very brief answer. 1.07. What is the difference between the highest and the second highest General Parity Index (GPI) in Sub-Saharan Africa (developing only)?
Give a very brief answer. 0. What is the difference between the highest and the second highest General Parity Index (GPI) in Central African Republic?
Provide a succinct answer. 0.02. What is the difference between the highest and the second highest General Parity Index (GPI) in Madagascar?
Make the answer very short. 0.02. What is the difference between the highest and the second highest General Parity Index (GPI) of Papua New Guinea?
Offer a very short reply. 0. What is the difference between the highest and the lowest General Parity Index (GPI) of Sub-Saharan Africa (developing only)?
Your answer should be compact. 0.04. What is the difference between the highest and the lowest General Parity Index (GPI) in Central African Republic?
Keep it short and to the point. 0.09. What is the difference between the highest and the lowest General Parity Index (GPI) in Madagascar?
Keep it short and to the point. 0.06. What is the difference between the highest and the lowest General Parity Index (GPI) in Papua New Guinea?
Provide a succinct answer. 0.05. 